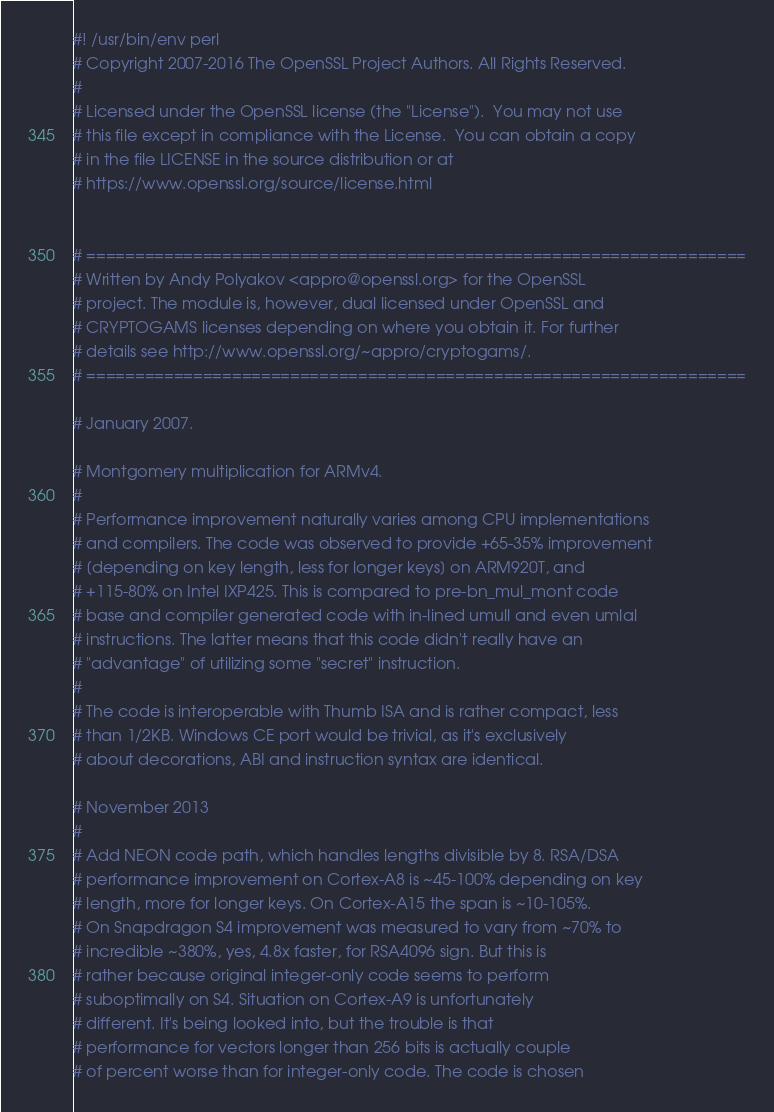Convert code to text. <code><loc_0><loc_0><loc_500><loc_500><_Perl_>#! /usr/bin/env perl
# Copyright 2007-2016 The OpenSSL Project Authors. All Rights Reserved.
#
# Licensed under the OpenSSL license (the "License").  You may not use
# this file except in compliance with the License.  You can obtain a copy
# in the file LICENSE in the source distribution or at
# https://www.openssl.org/source/license.html


# ====================================================================
# Written by Andy Polyakov <appro@openssl.org> for the OpenSSL
# project. The module is, however, dual licensed under OpenSSL and
# CRYPTOGAMS licenses depending on where you obtain it. For further
# details see http://www.openssl.org/~appro/cryptogams/.
# ====================================================================

# January 2007.

# Montgomery multiplication for ARMv4.
#
# Performance improvement naturally varies among CPU implementations
# and compilers. The code was observed to provide +65-35% improvement
# [depending on key length, less for longer keys] on ARM920T, and
# +115-80% on Intel IXP425. This is compared to pre-bn_mul_mont code
# base and compiler generated code with in-lined umull and even umlal
# instructions. The latter means that this code didn't really have an
# "advantage" of utilizing some "secret" instruction.
#
# The code is interoperable with Thumb ISA and is rather compact, less
# than 1/2KB. Windows CE port would be trivial, as it's exclusively
# about decorations, ABI and instruction syntax are identical.

# November 2013
#
# Add NEON code path, which handles lengths divisible by 8. RSA/DSA
# performance improvement on Cortex-A8 is ~45-100% depending on key
# length, more for longer keys. On Cortex-A15 the span is ~10-105%.
# On Snapdragon S4 improvement was measured to vary from ~70% to
# incredible ~380%, yes, 4.8x faster, for RSA4096 sign. But this is
# rather because original integer-only code seems to perform
# suboptimally on S4. Situation on Cortex-A9 is unfortunately
# different. It's being looked into, but the trouble is that
# performance for vectors longer than 256 bits is actually couple
# of percent worse than for integer-only code. The code is chosen</code> 